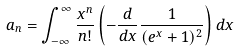<formula> <loc_0><loc_0><loc_500><loc_500>a _ { n } = \int _ { - \infty } ^ { \infty } \frac { x ^ { n } } { n ! } \left ( - \frac { d } { d x } \frac { 1 } { ( e ^ { x } + 1 ) ^ { 2 } } \right ) d x</formula> 